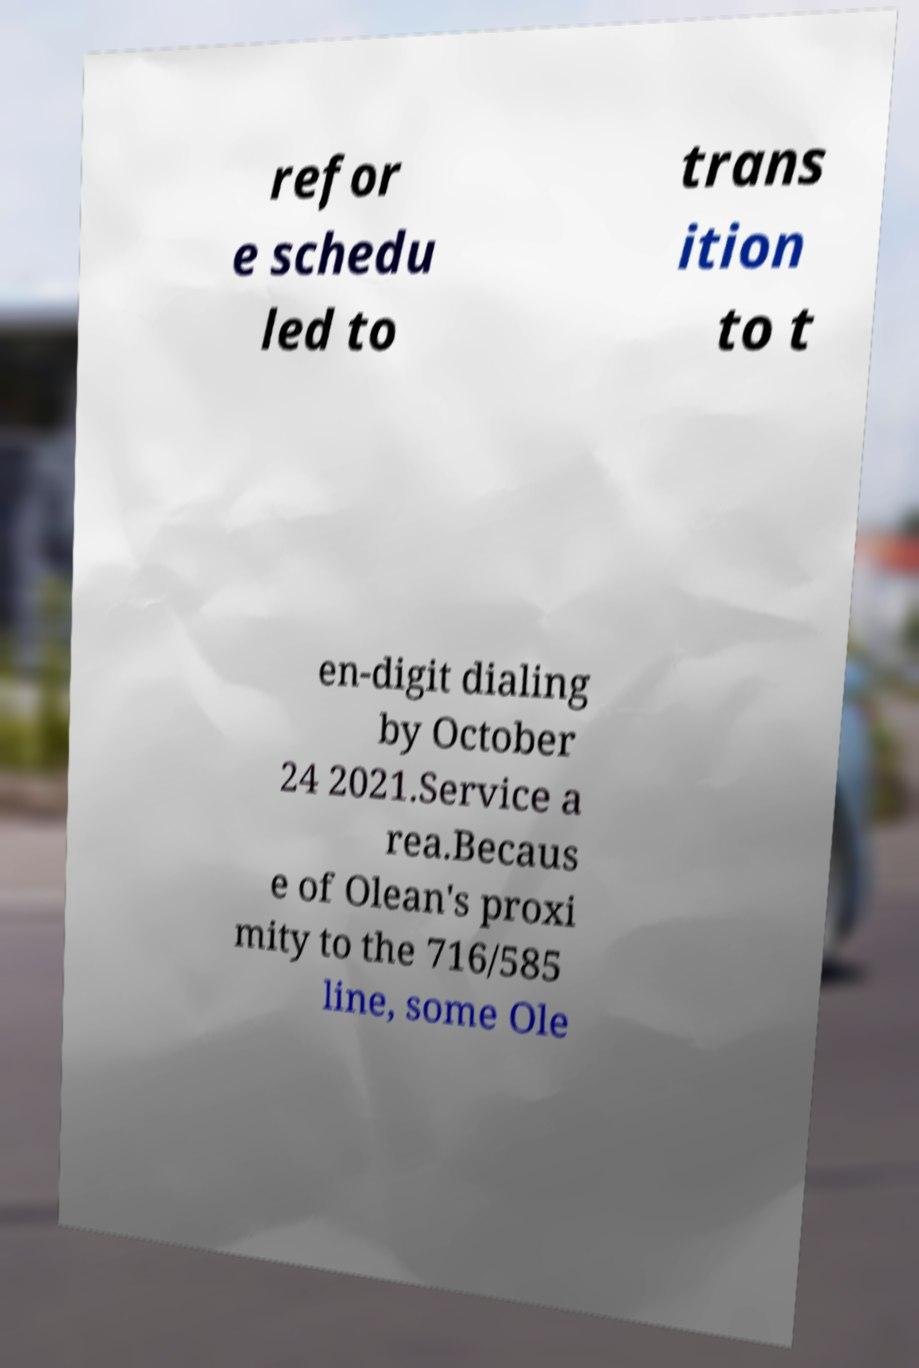Could you extract and type out the text from this image? refor e schedu led to trans ition to t en-digit dialing by October 24 2021.Service a rea.Becaus e of Olean's proxi mity to the 716/585 line, some Ole 